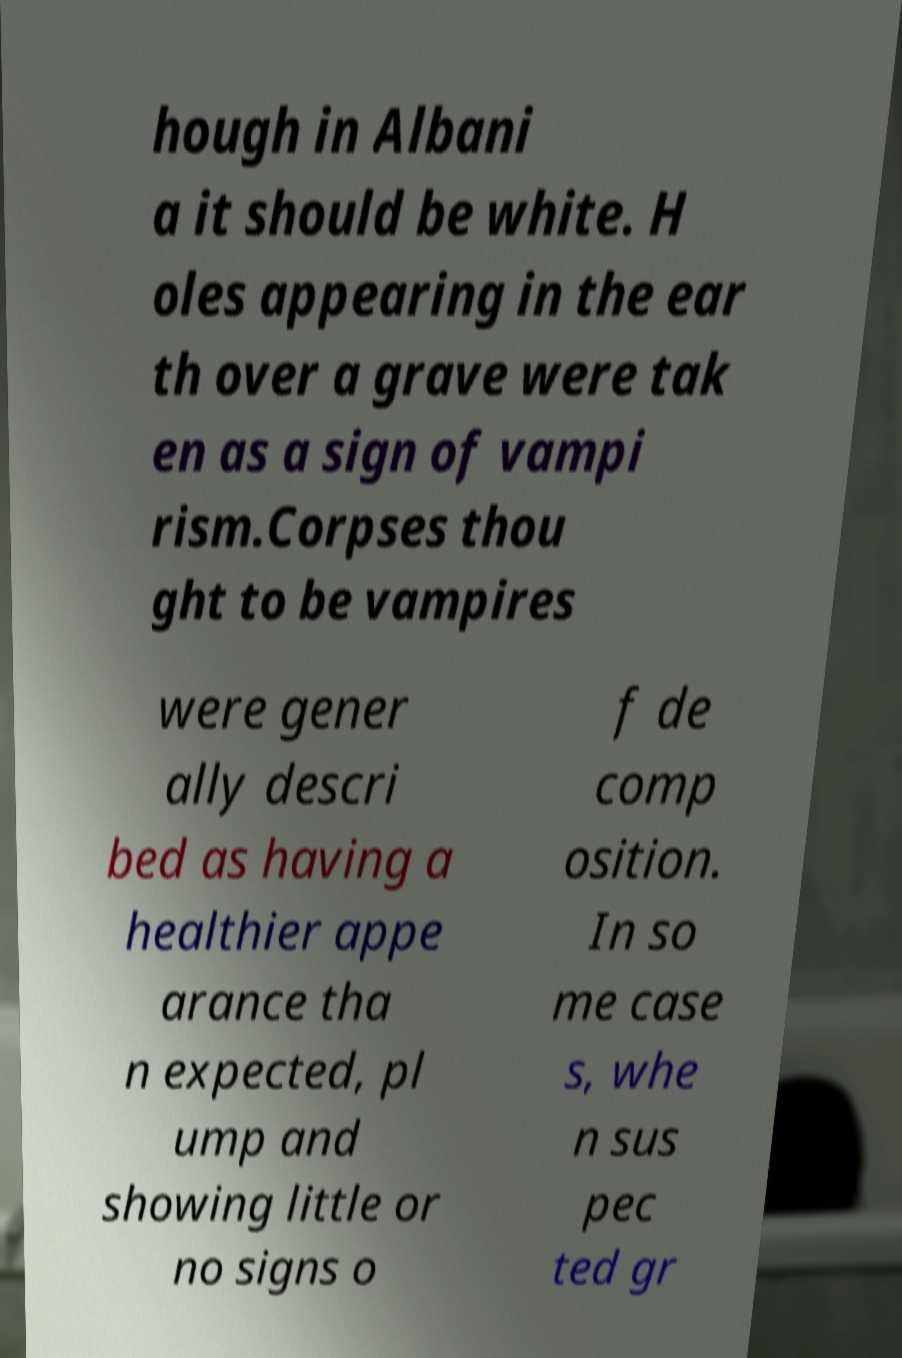What messages or text are displayed in this image? I need them in a readable, typed format. hough in Albani a it should be white. H oles appearing in the ear th over a grave were tak en as a sign of vampi rism.Corpses thou ght to be vampires were gener ally descri bed as having a healthier appe arance tha n expected, pl ump and showing little or no signs o f de comp osition. In so me case s, whe n sus pec ted gr 